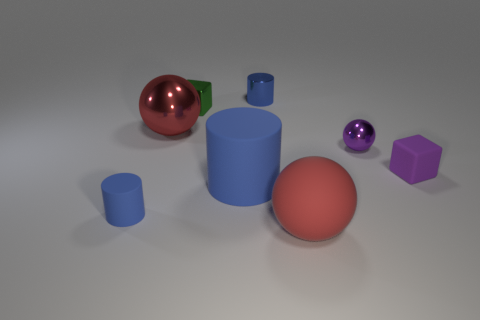Subtract 1 spheres. How many spheres are left? 2 Add 1 blue rubber objects. How many objects exist? 9 Subtract all cylinders. How many objects are left? 5 Add 7 large shiny balls. How many large shiny balls exist? 8 Subtract 0 cyan spheres. How many objects are left? 8 Subtract all big matte things. Subtract all big blue rubber cylinders. How many objects are left? 5 Add 3 large metal balls. How many large metal balls are left? 4 